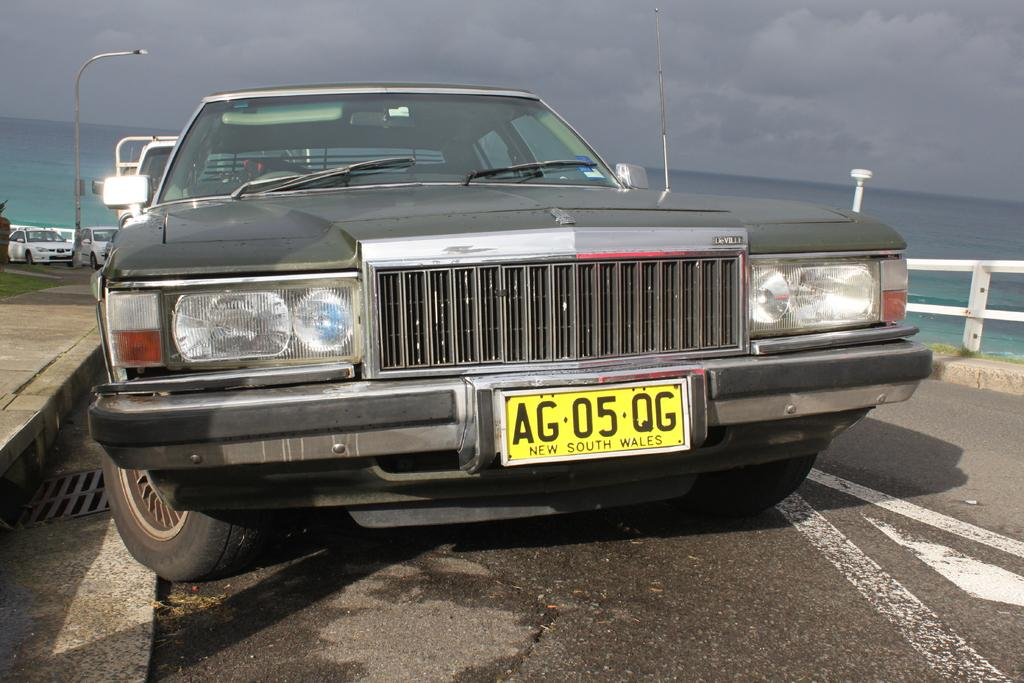What type of vehicles are parked in the image? There are cars parked in the image. What natural element is visible in the image? There is water visible in the image. What type of barrier is present in the image? There is a metal fence in the image. What type of lighting is present in the image? There are pole lights in the image. What is the condition of the sky in the image? The sky appears to be cloudy in the image. Where is the seed located in the image? There is no seed present in the image. What type of mask is being worn by the cars in the image? There are no masks present in the image; the subject is cars, not people or animals. 